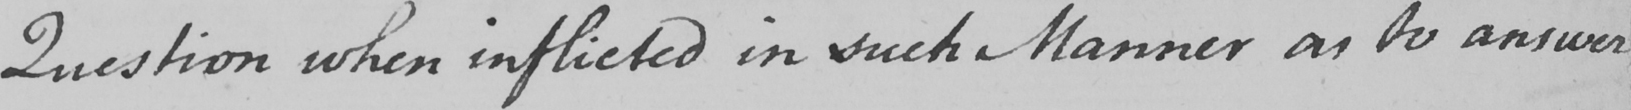Can you tell me what this handwritten text says? Question when inflicted in such Manner as to answer 